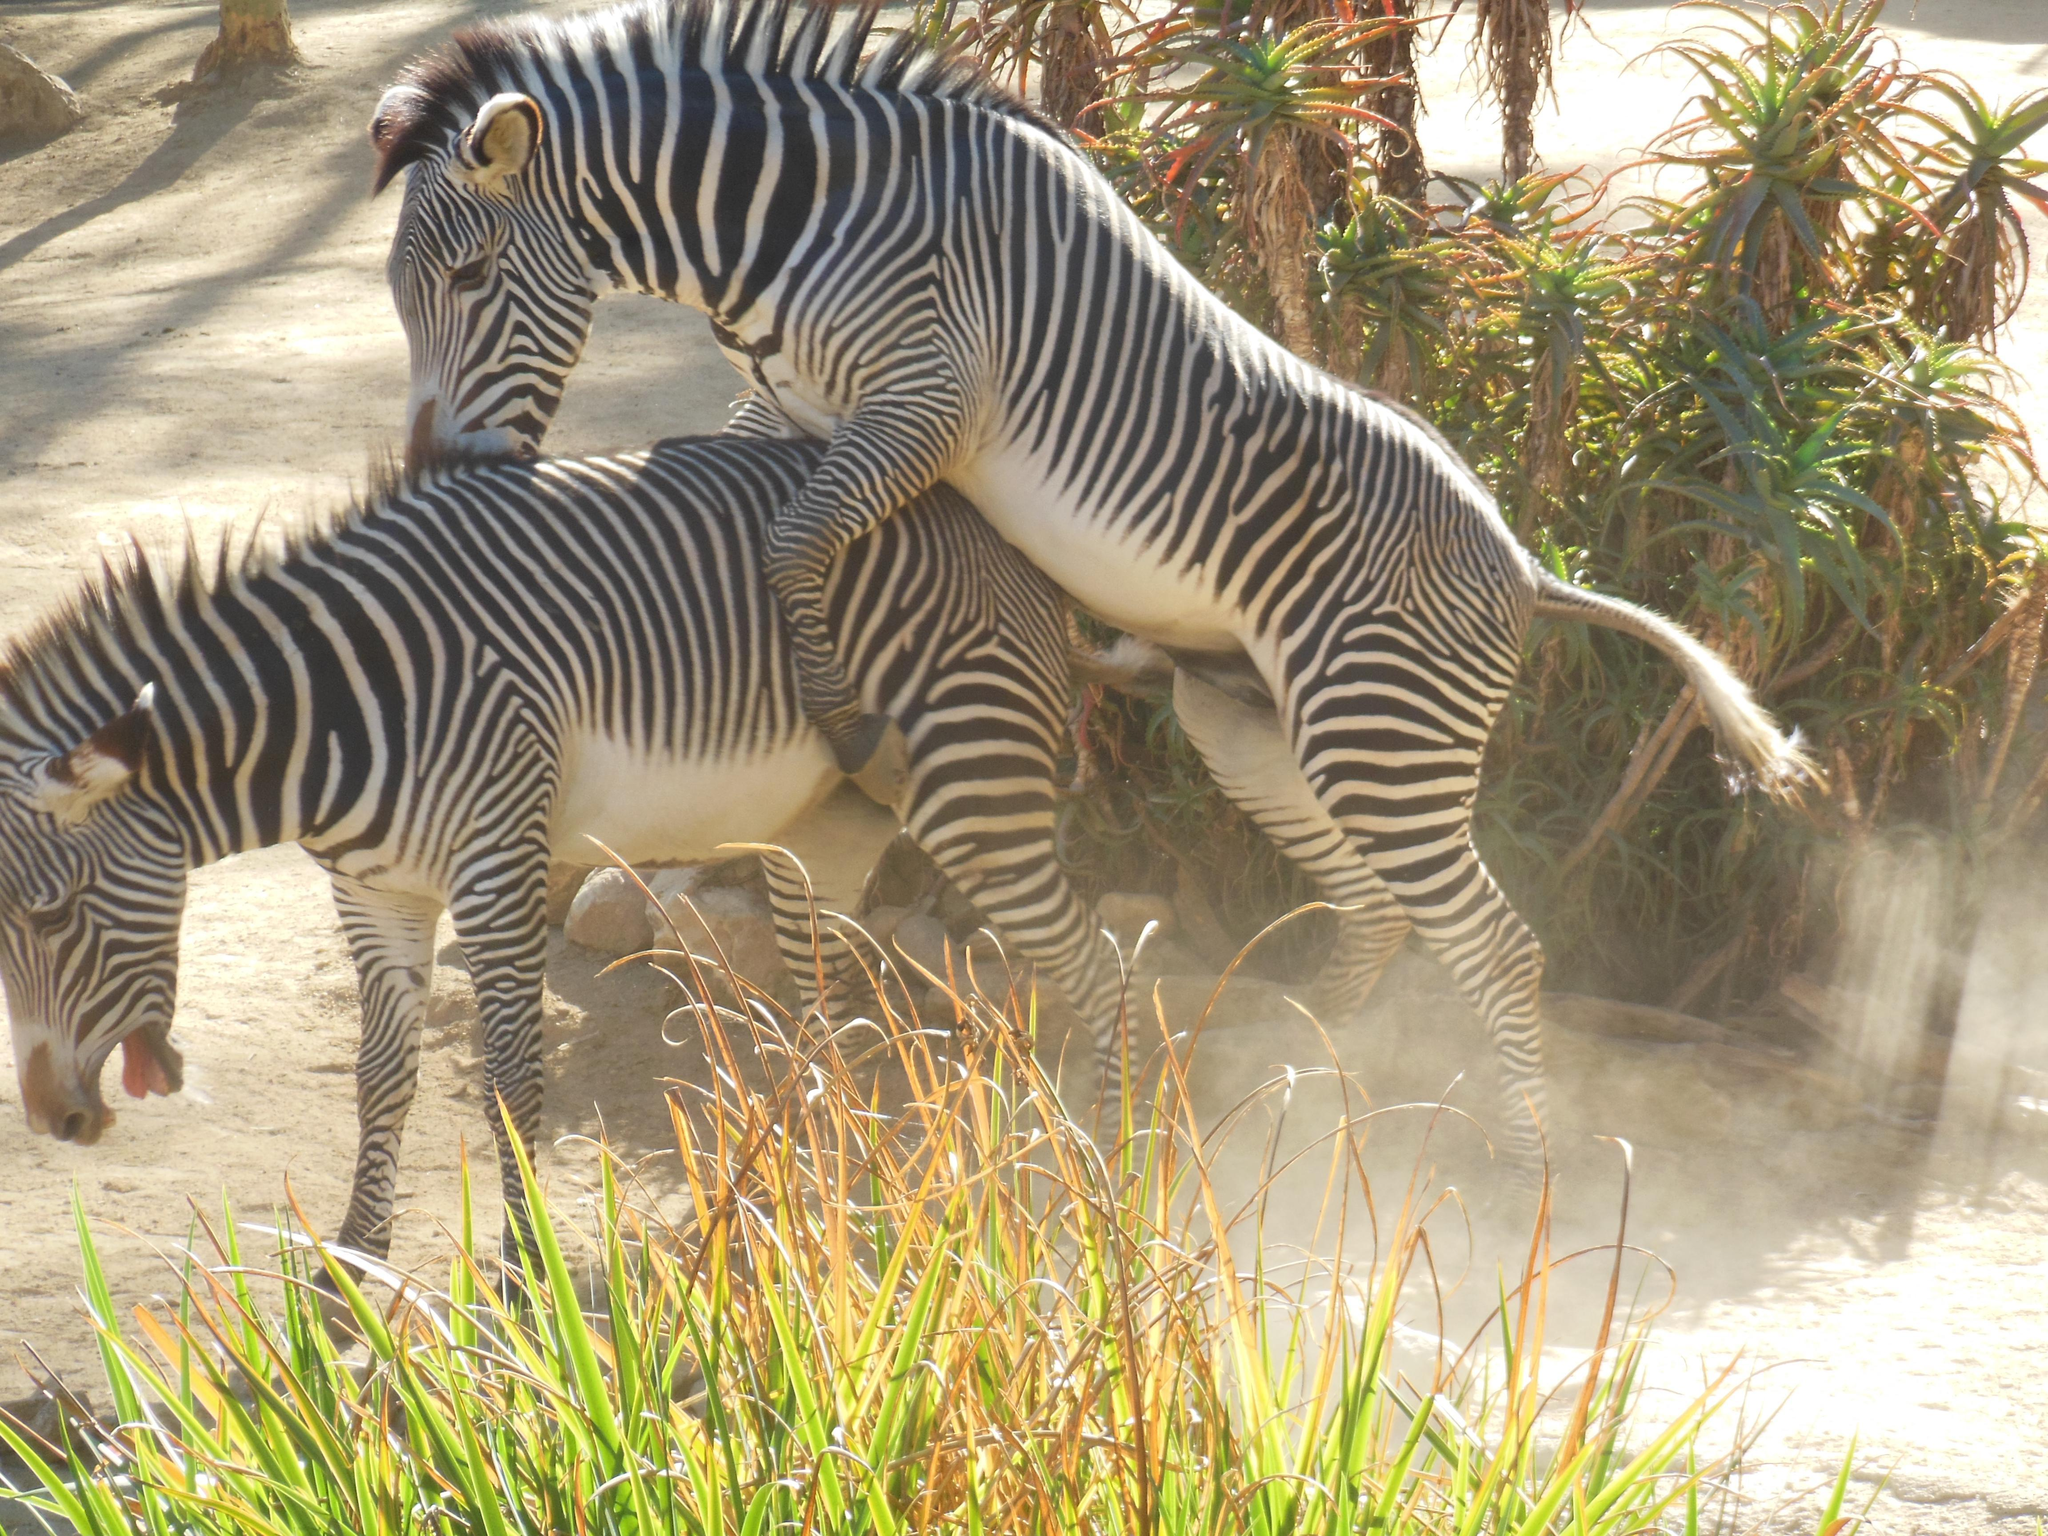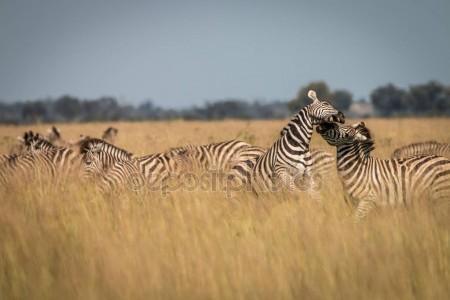The first image is the image on the left, the second image is the image on the right. Analyze the images presented: Is the assertion "In at least one image there is a mother and calf zebra touching noses." valid? Answer yes or no. No. 